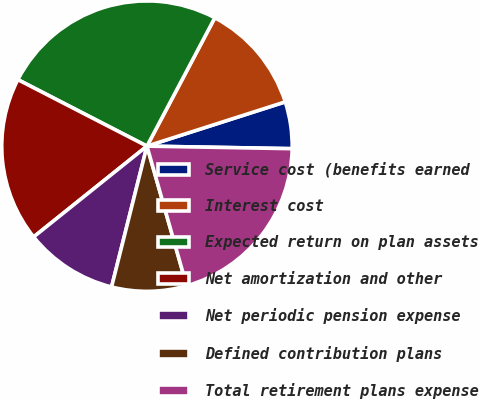Convert chart to OTSL. <chart><loc_0><loc_0><loc_500><loc_500><pie_chart><fcel>Service cost (benefits earned<fcel>Interest cost<fcel>Expected return on plan assets<fcel>Net amortization and other<fcel>Net periodic pension expense<fcel>Defined contribution plans<fcel>Total retirement plans expense<nl><fcel>5.21%<fcel>12.33%<fcel>25.17%<fcel>18.32%<fcel>10.33%<fcel>8.33%<fcel>20.31%<nl></chart> 